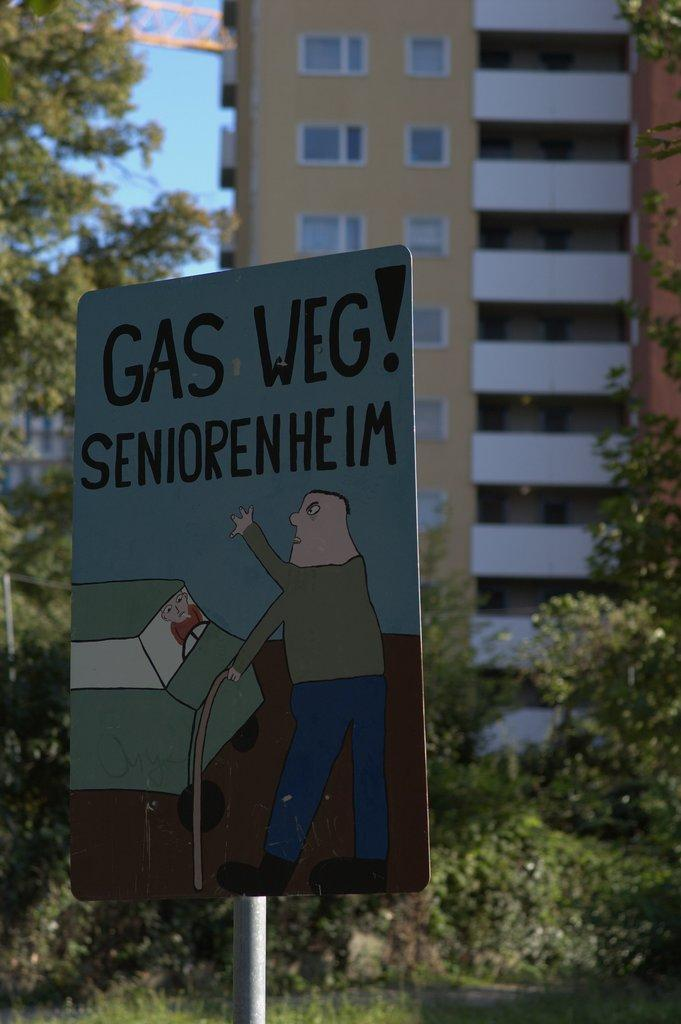What is the main object in the image with a pole? There is a board with a pole in the image. What type of structure can be seen in the image? There is a building in the image. What type of vegetation is present in the image? There are trees in the image. What can be seen in the background of the image? The sky is visible in the background of the image. What is the distribution of squares in the image? There are no squares present in the image. Which direction is the north in the image? The image does not provide any information about the direction of north. 